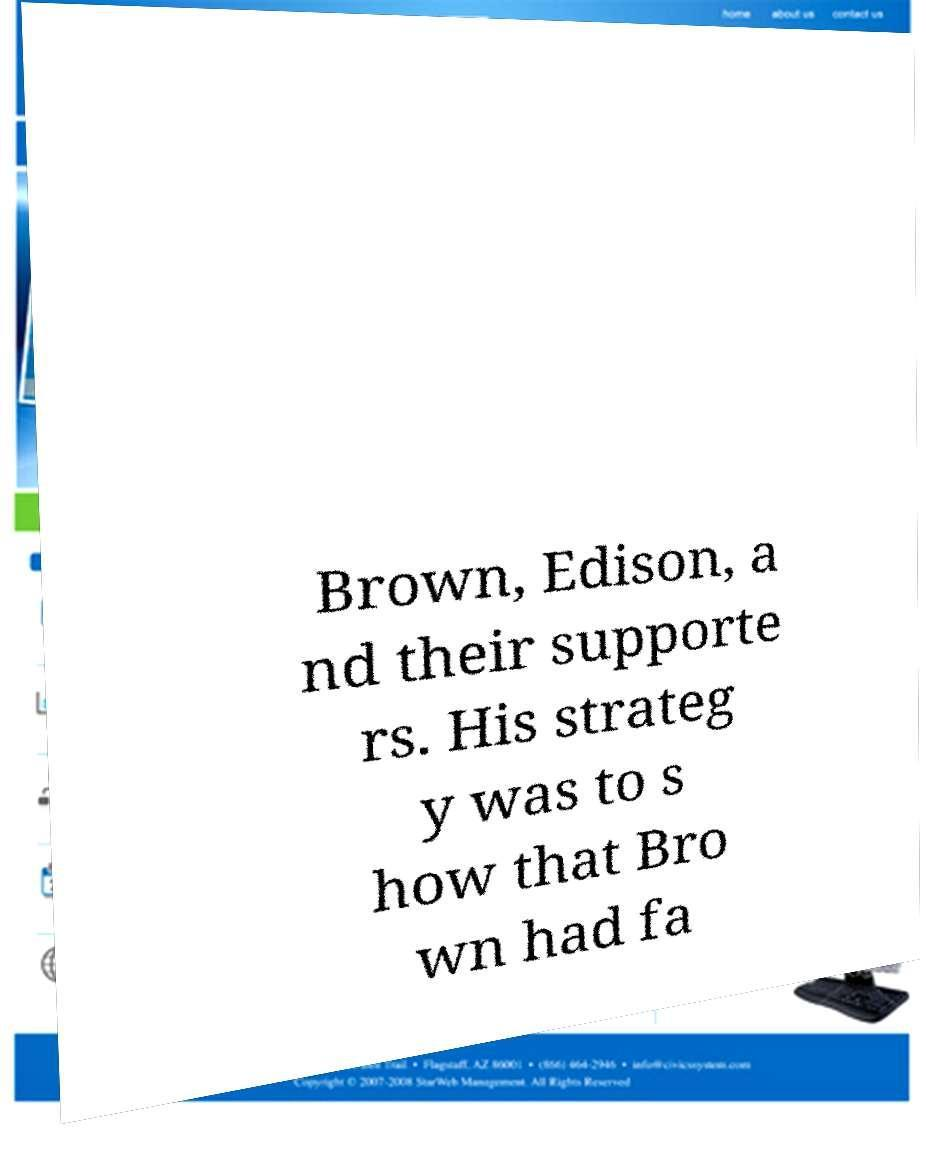Could you assist in decoding the text presented in this image and type it out clearly? Brown, Edison, a nd their supporte rs. His strateg y was to s how that Bro wn had fa 